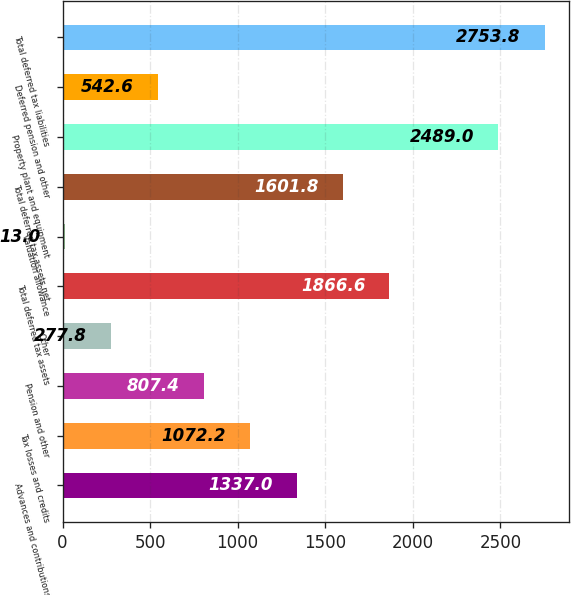<chart> <loc_0><loc_0><loc_500><loc_500><bar_chart><fcel>Advances and contributions<fcel>Tax losses and credits<fcel>Pension and other<fcel>Other<fcel>Total deferred tax assets<fcel>Valuation allowance<fcel>Total deferred tax assets net<fcel>Property plant and equipment<fcel>Deferred pension and other<fcel>Total deferred tax liabilities<nl><fcel>1337<fcel>1072.2<fcel>807.4<fcel>277.8<fcel>1866.6<fcel>13<fcel>1601.8<fcel>2489<fcel>542.6<fcel>2753.8<nl></chart> 